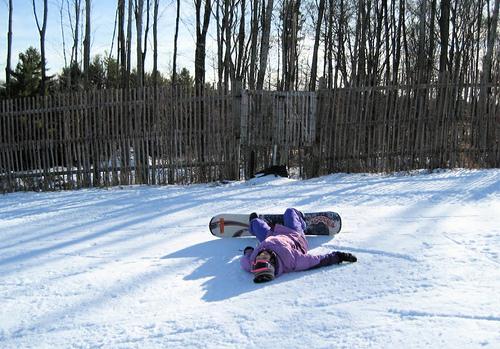Is this girl standing up?
Keep it brief. No. What color winter coat is the girl wearing?
Be succinct. Purple. What kind of eyewear is the girl wearing on her head?
Give a very brief answer. Goggles. 